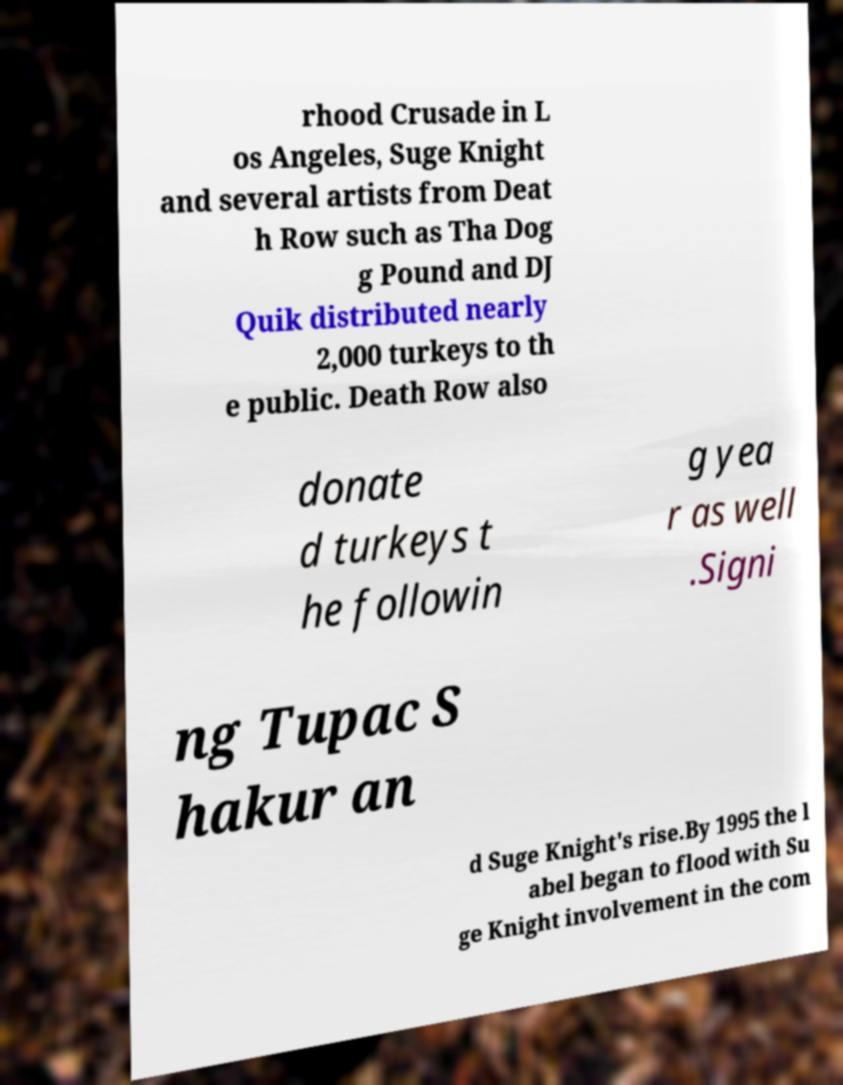There's text embedded in this image that I need extracted. Can you transcribe it verbatim? rhood Crusade in L os Angeles, Suge Knight and several artists from Deat h Row such as Tha Dog g Pound and DJ Quik distributed nearly 2,000 turkeys to th e public. Death Row also donate d turkeys t he followin g yea r as well .Signi ng Tupac S hakur an d Suge Knight's rise.By 1995 the l abel began to flood with Su ge Knight involvement in the com 